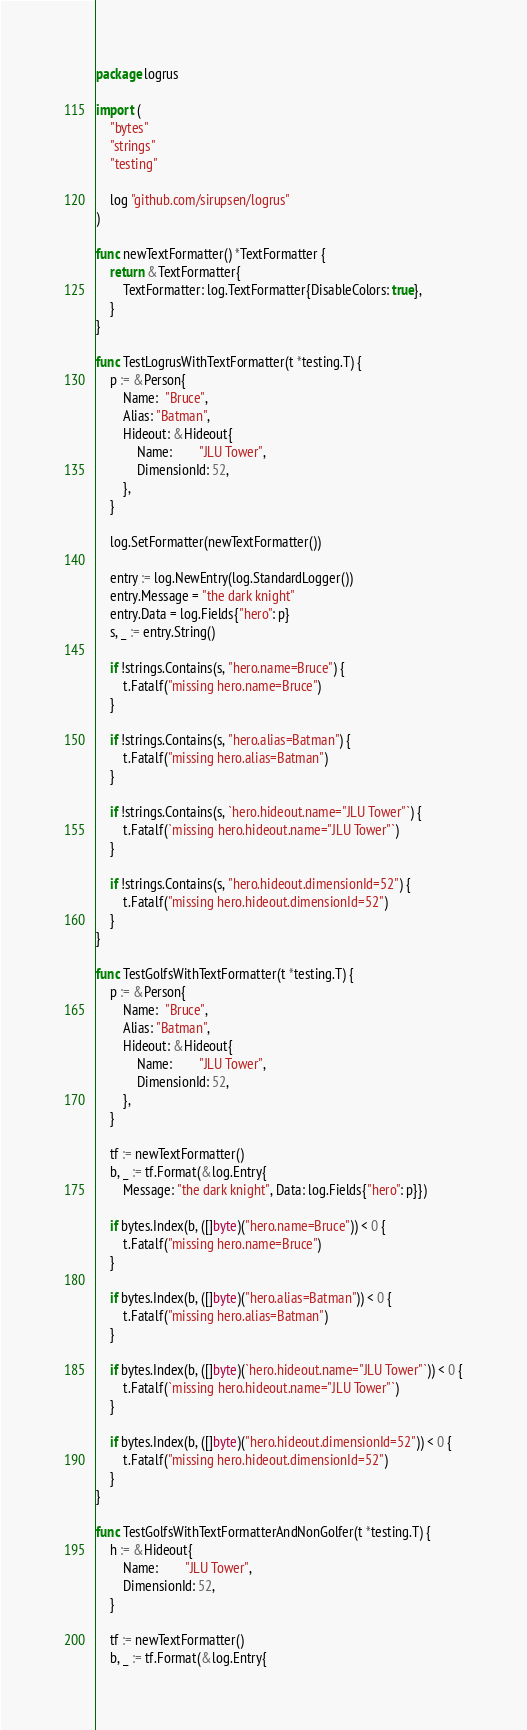<code> <loc_0><loc_0><loc_500><loc_500><_Go_>package logrus

import (
	"bytes"
	"strings"
	"testing"

	log "github.com/sirupsen/logrus"
)

func newTextFormatter() *TextFormatter {
	return &TextFormatter{
		TextFormatter: log.TextFormatter{DisableColors: true},
	}
}

func TestLogrusWithTextFormatter(t *testing.T) {
	p := &Person{
		Name:  "Bruce",
		Alias: "Batman",
		Hideout: &Hideout{
			Name:        "JLU Tower",
			DimensionId: 52,
		},
	}

	log.SetFormatter(newTextFormatter())

	entry := log.NewEntry(log.StandardLogger())
	entry.Message = "the dark knight"
	entry.Data = log.Fields{"hero": p}
	s, _ := entry.String()

	if !strings.Contains(s, "hero.name=Bruce") {
		t.Fatalf("missing hero.name=Bruce")
	}

	if !strings.Contains(s, "hero.alias=Batman") {
		t.Fatalf("missing hero.alias=Batman")
	}

	if !strings.Contains(s, `hero.hideout.name="JLU Tower"`) {
		t.Fatalf(`missing hero.hideout.name="JLU Tower"`)
	}

	if !strings.Contains(s, "hero.hideout.dimensionId=52") {
		t.Fatalf("missing hero.hideout.dimensionId=52")
	}
}

func TestGolfsWithTextFormatter(t *testing.T) {
	p := &Person{
		Name:  "Bruce",
		Alias: "Batman",
		Hideout: &Hideout{
			Name:        "JLU Tower",
			DimensionId: 52,
		},
	}

	tf := newTextFormatter()
	b, _ := tf.Format(&log.Entry{
		Message: "the dark knight", Data: log.Fields{"hero": p}})

	if bytes.Index(b, ([]byte)("hero.name=Bruce")) < 0 {
		t.Fatalf("missing hero.name=Bruce")
	}

	if bytes.Index(b, ([]byte)("hero.alias=Batman")) < 0 {
		t.Fatalf("missing hero.alias=Batman")
	}

	if bytes.Index(b, ([]byte)(`hero.hideout.name="JLU Tower"`)) < 0 {
		t.Fatalf(`missing hero.hideout.name="JLU Tower"`)
	}

	if bytes.Index(b, ([]byte)("hero.hideout.dimensionId=52")) < 0 {
		t.Fatalf("missing hero.hideout.dimensionId=52")
	}
}

func TestGolfsWithTextFormatterAndNonGolfer(t *testing.T) {
	h := &Hideout{
		Name:        "JLU Tower",
		DimensionId: 52,
	}

	tf := newTextFormatter()
	b, _ := tf.Format(&log.Entry{</code> 